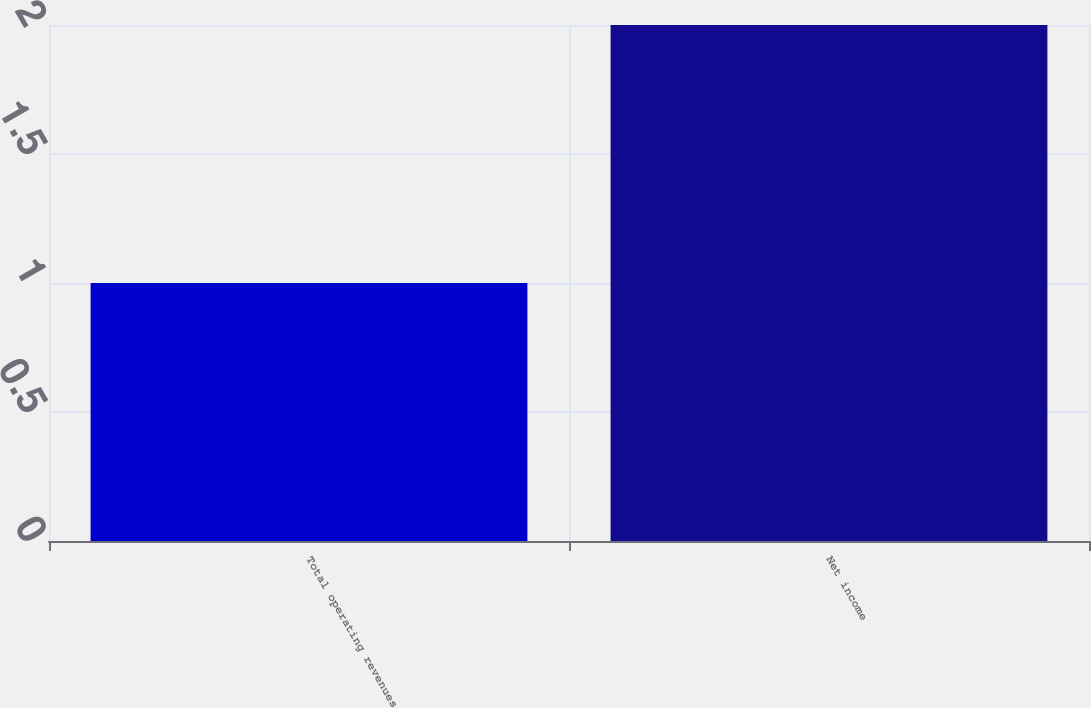Convert chart to OTSL. <chart><loc_0><loc_0><loc_500><loc_500><bar_chart><fcel>Total operating revenues<fcel>Net income<nl><fcel>1<fcel>2<nl></chart> 